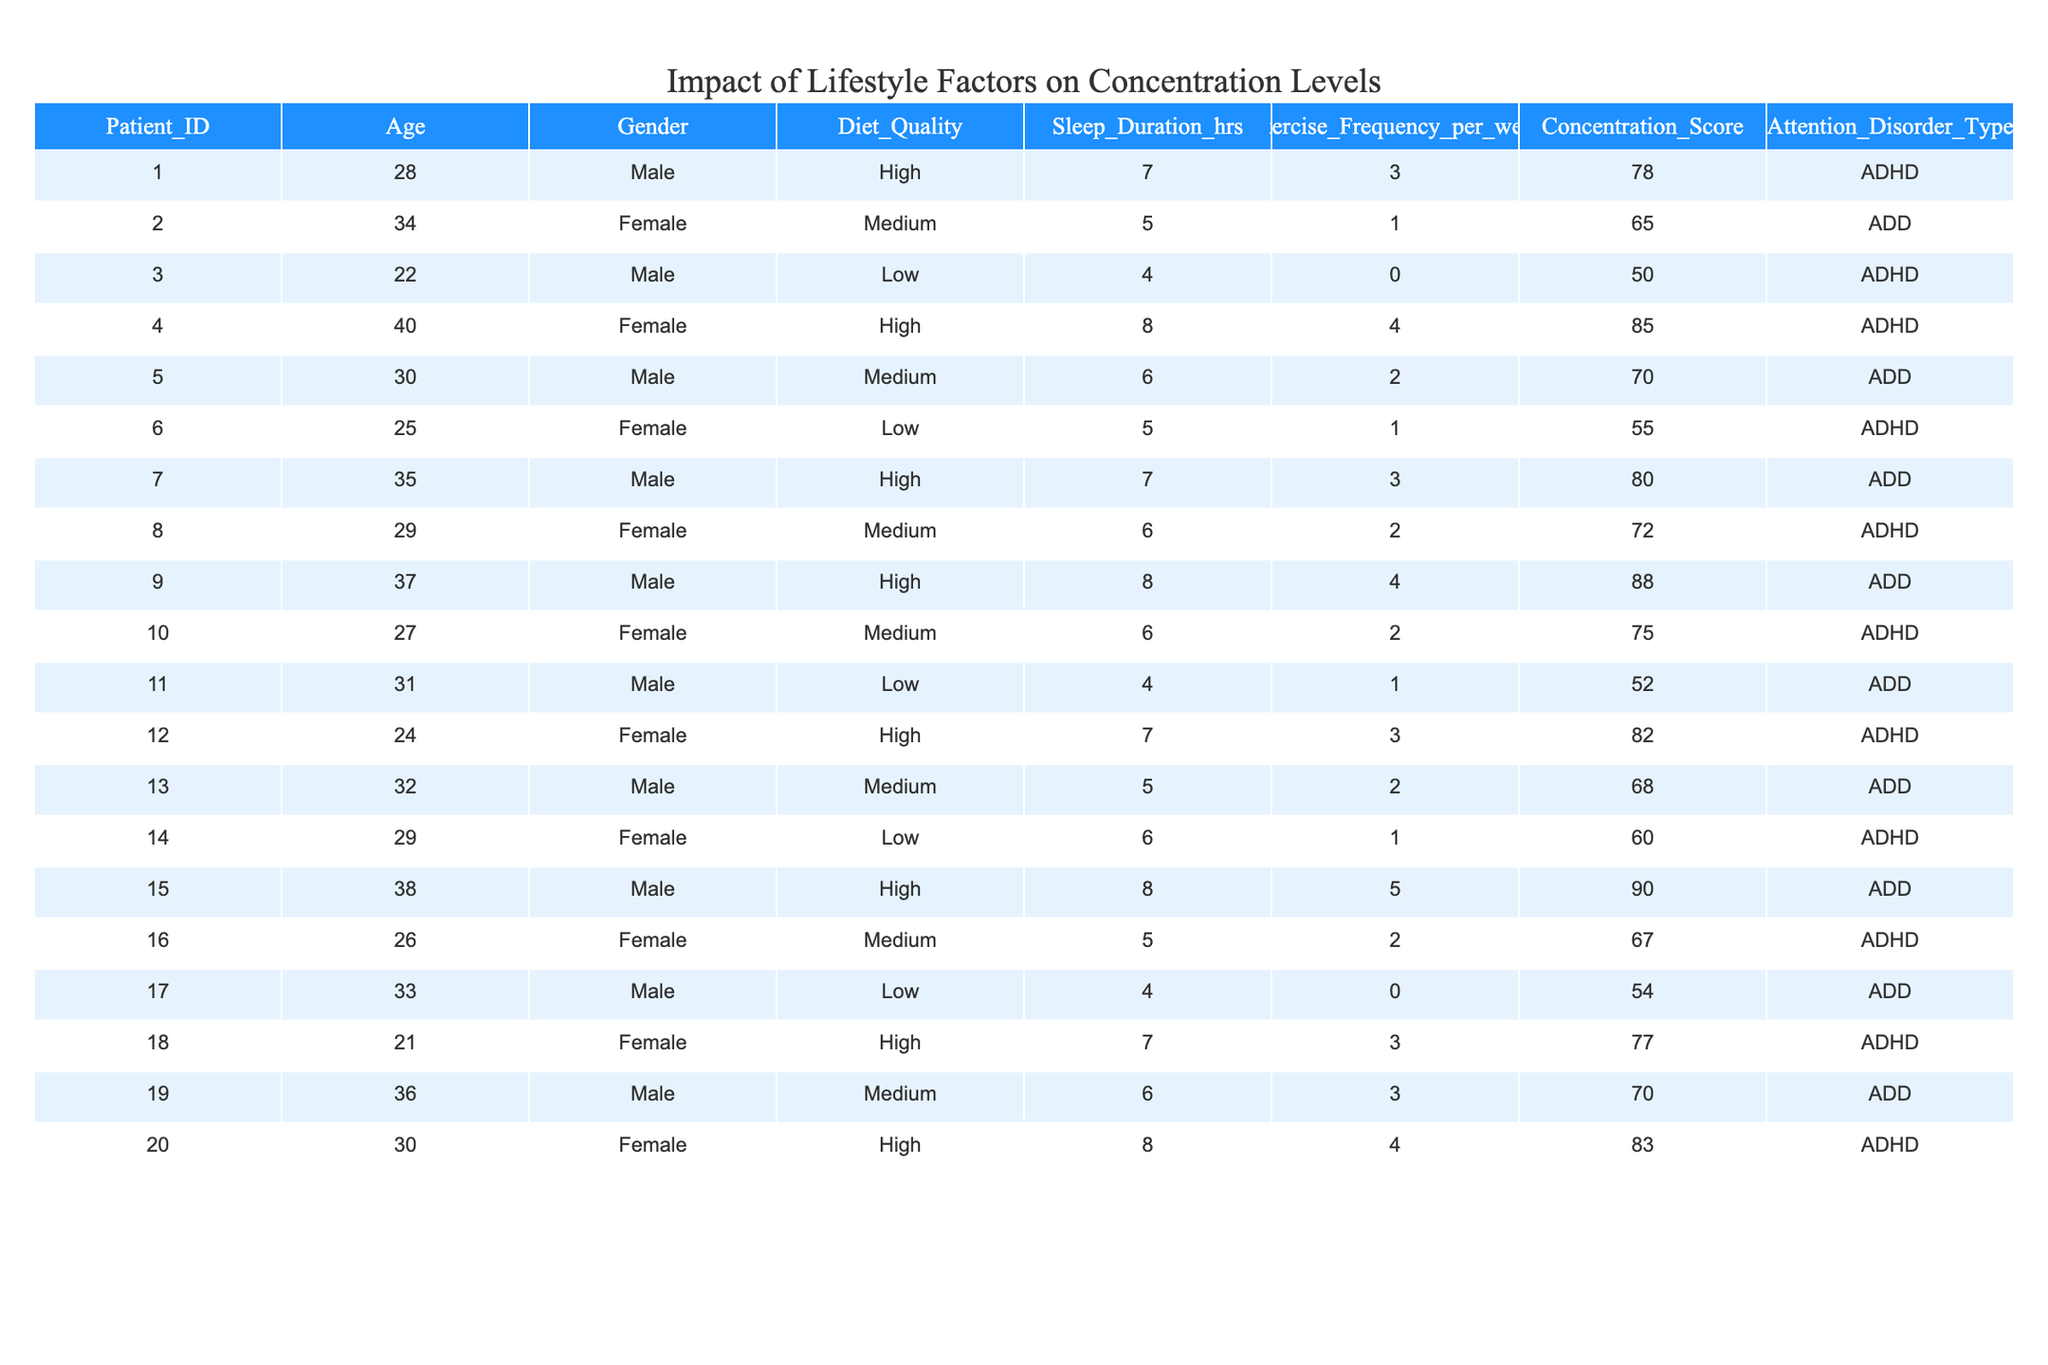What is the concentration score of the patient with the highest sleep duration? The patient with the highest sleep duration is patient 15 with 8 hours of sleep. Their concentration score is 90.
Answer: 90 How many patients have a high-quality diet? Looking at the table, patients 1, 4, 7, 9, 12, 15, and 18 have a high-quality diet, totaling 7 patients.
Answer: 7 What is the average concentration score of patients who exercise 4 times a week? There are 3 patients who exercise 4 times a week (patients 4, 9, and 20). Their concentration scores are 85, 88, and 83. The average is (85 + 88 + 83) / 3 = 85.33.
Answer: 85.33 True or False: The majority of patients with a medium diet quality have a higher concentration score than those with a low diet quality. The average concentration score for medium diet quality patients is (65 + 70 + 72 + 68) / 4 = 68.75, while for low diet quality patients, it is (50 + 55 + 52 + 60 + 54) / 5 = 54. Therefore, it is true.
Answer: True What concentration score is associated with the youngest patient? The youngest patient, patient 18, who is 21 years old, has a concentration score of 77.
Answer: 77 How many patients have both high-quality diets and high concentration scores? Patients 1, 4, 7, 9, 12, and 15 have high-quality diets, and their scores are 78, 85, 80, 88, 82, and 90 respectively. All of them scored above 75, which indicates they have high concentration scores. Thus, there are 6 patients.
Answer: 6 Which attention disorder type corresponds to the patient with the lowest concentration score? Patient 3 has the lowest concentration score of 50 and is diagnosed with ADHD.
Answer: ADHD What is the difference in concentration scores between male and female patients overall? The average concentration score for male patients is (78 + 50 + 70 + 80 + 88 + 52 + 54) / 7 = 70.57, and for female patients, it is (65 + 55 + 72 + 75 + 82 + 67 + 77 + 83) / 8 = 73.875. The difference is 73.875 - 70.57 = 3.305.
Answer: 3.305 Which patient has the lowest exercise frequency and what is their concentration score? Patient 3 has an exercise frequency of 0 and a concentration score of 50.
Answer: 50 Are there any patients with low diet quality who have a concentration score above 60? Reviewing the table, only patient 14 with a low diet quality scored 60, so there are no patients with a score above 60.
Answer: No 